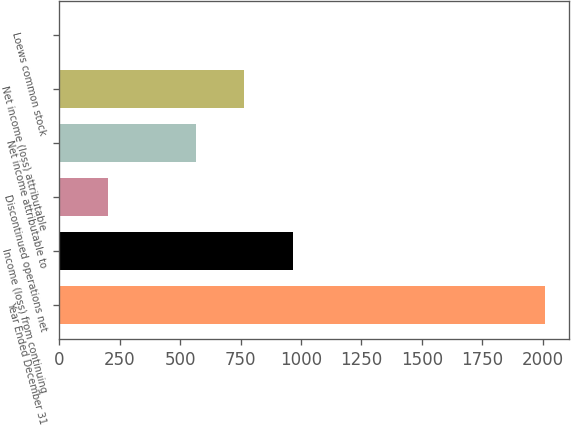Convert chart. <chart><loc_0><loc_0><loc_500><loc_500><bar_chart><fcel>Year Ended December 31<fcel>Income (loss) from continuing<fcel>Discontinued operations net<fcel>Net income attributable to<fcel>Net income (loss) attributable<fcel>Loews common stock<nl><fcel>2009<fcel>965.54<fcel>202.07<fcel>564<fcel>764.77<fcel>1.3<nl></chart> 